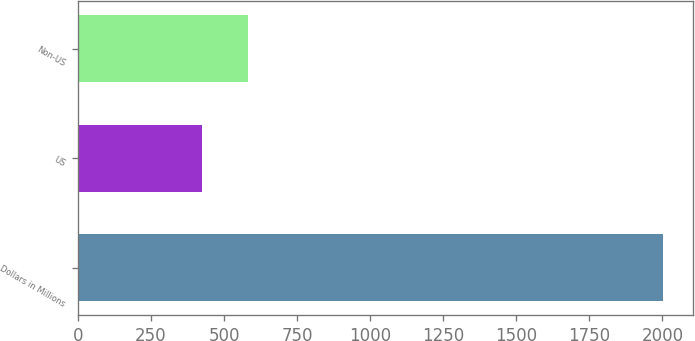Convert chart to OTSL. <chart><loc_0><loc_0><loc_500><loc_500><bar_chart><fcel>Dollars in Millions<fcel>US<fcel>Non-US<nl><fcel>2003<fcel>423<fcel>581<nl></chart> 